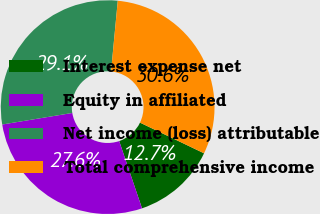Convert chart. <chart><loc_0><loc_0><loc_500><loc_500><pie_chart><fcel>Interest expense net<fcel>Equity in affiliated<fcel>Net income (loss) attributable<fcel>Total comprehensive income<nl><fcel>12.68%<fcel>27.61%<fcel>29.11%<fcel>30.6%<nl></chart> 